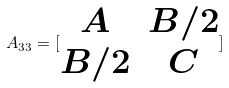<formula> <loc_0><loc_0><loc_500><loc_500>A _ { 3 3 } = [ \begin{matrix} A & B / 2 \\ B / 2 & C \end{matrix} ]</formula> 